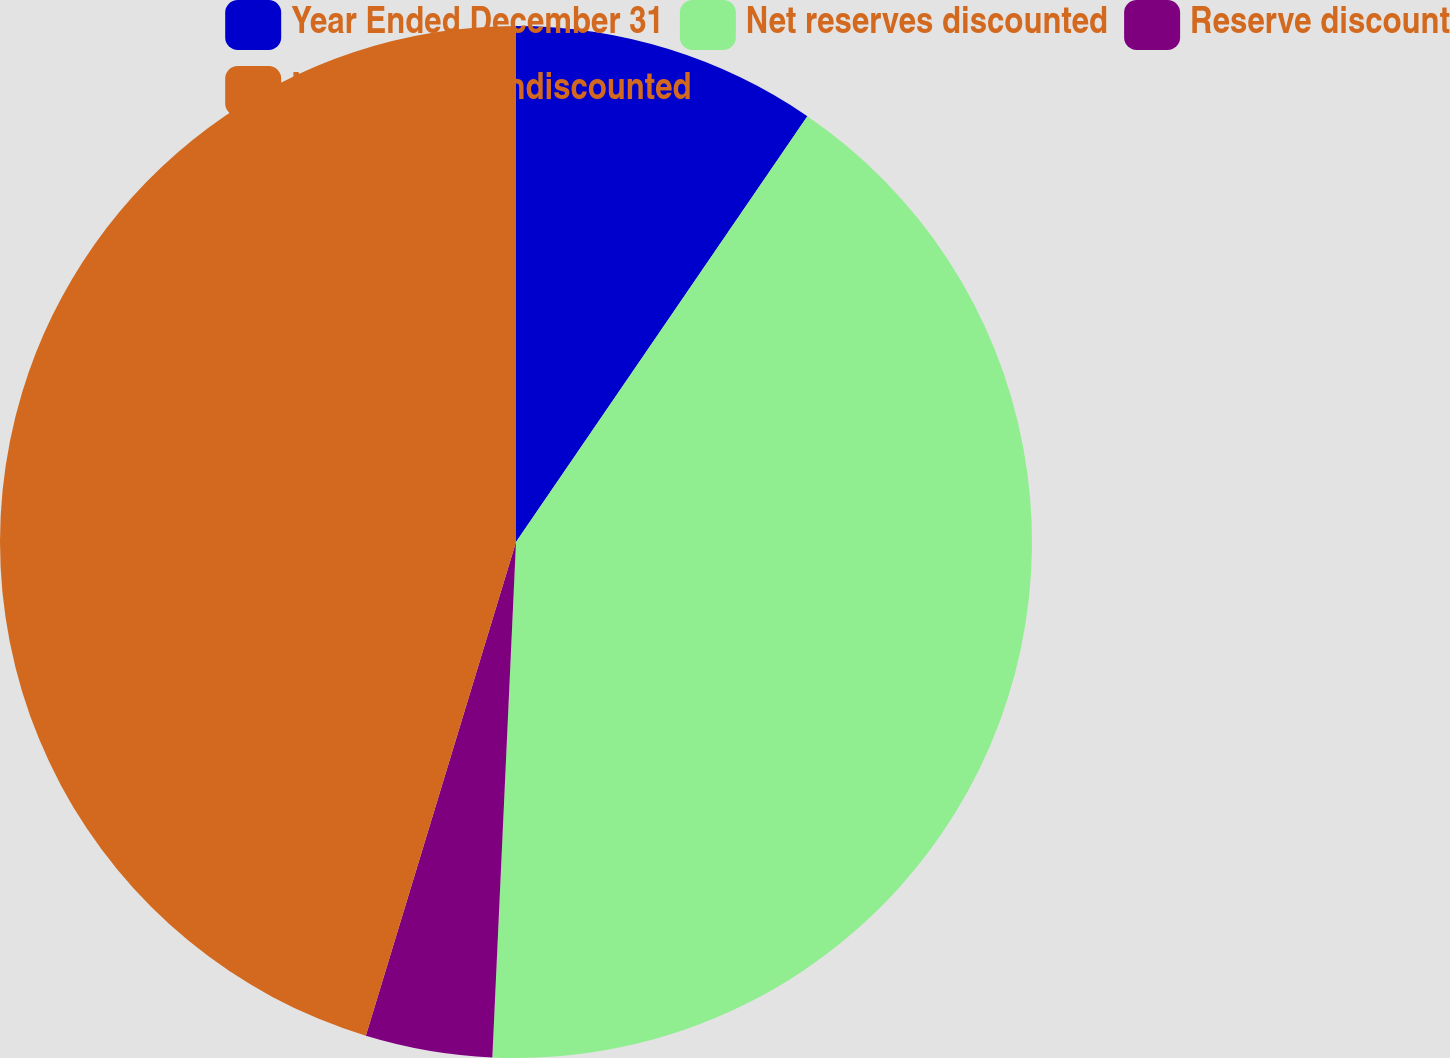<chart> <loc_0><loc_0><loc_500><loc_500><pie_chart><fcel>Year Ended December 31<fcel>Net reserves discounted<fcel>Reserve discount<fcel>Net reserves undiscounted<nl><fcel>9.55%<fcel>41.18%<fcel>3.97%<fcel>45.3%<nl></chart> 